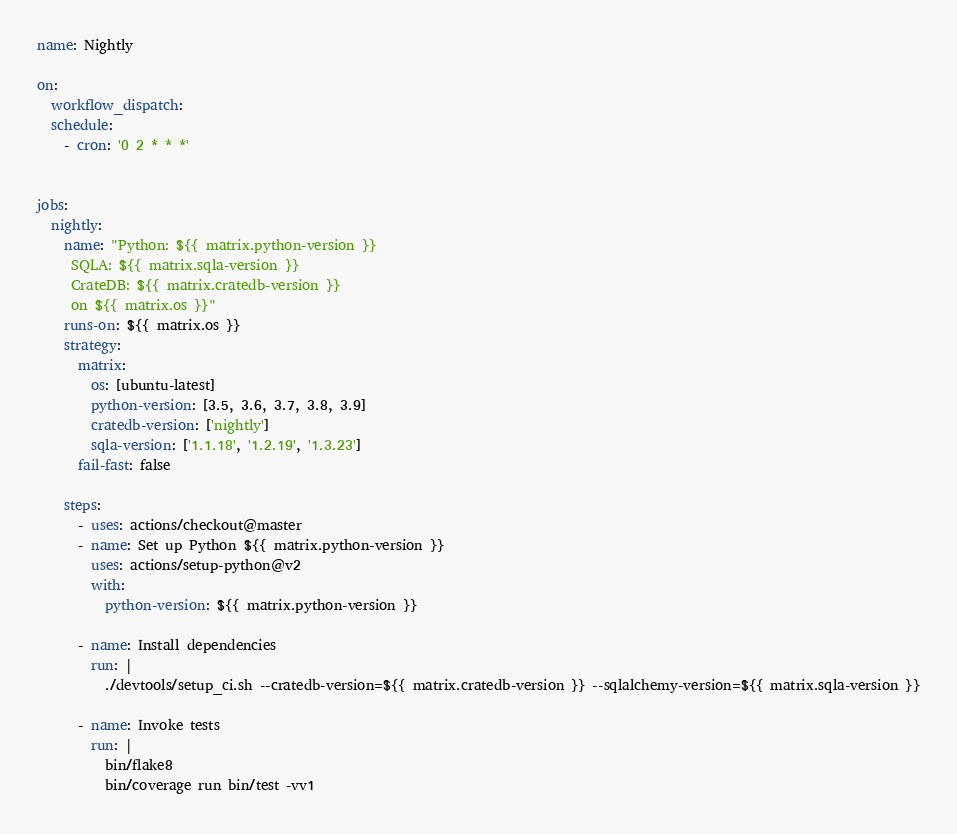<code> <loc_0><loc_0><loc_500><loc_500><_YAML_>name: Nightly

on:
  workflow_dispatch:
  schedule:
    - cron: '0 2 * * *'


jobs:
  nightly:
    name: "Python: ${{ matrix.python-version }}
     SQLA: ${{ matrix.sqla-version }}
     CrateDB: ${{ matrix.cratedb-version }}
     on ${{ matrix.os }}"
    runs-on: ${{ matrix.os }}
    strategy:
      matrix:
        os: [ubuntu-latest]
        python-version: [3.5, 3.6, 3.7, 3.8, 3.9]
        cratedb-version: ['nightly']
        sqla-version: ['1.1.18', '1.2.19', '1.3.23']
      fail-fast: false

    steps:
      - uses: actions/checkout@master
      - name: Set up Python ${{ matrix.python-version }}
        uses: actions/setup-python@v2
        with:
          python-version: ${{ matrix.python-version }}

      - name: Install dependencies
        run: |
          ./devtools/setup_ci.sh --cratedb-version=${{ matrix.cratedb-version }} --sqlalchemy-version=${{ matrix.sqla-version }}

      - name: Invoke tests
        run: |
          bin/flake8
          bin/coverage run bin/test -vv1
</code> 